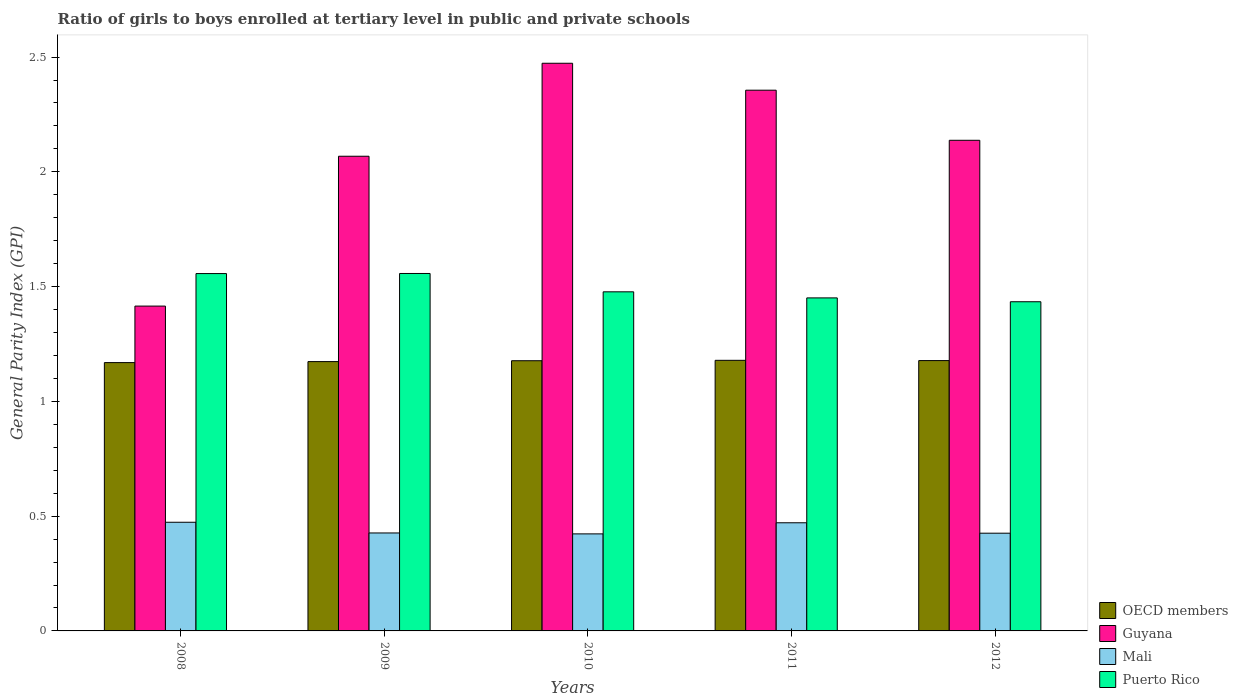How many different coloured bars are there?
Offer a very short reply. 4. How many groups of bars are there?
Provide a succinct answer. 5. Are the number of bars per tick equal to the number of legend labels?
Offer a very short reply. Yes. How many bars are there on the 4th tick from the left?
Keep it short and to the point. 4. In how many cases, is the number of bars for a given year not equal to the number of legend labels?
Offer a very short reply. 0. What is the general parity index in Guyana in 2011?
Your response must be concise. 2.36. Across all years, what is the maximum general parity index in Mali?
Offer a terse response. 0.47. Across all years, what is the minimum general parity index in Puerto Rico?
Provide a short and direct response. 1.43. In which year was the general parity index in Puerto Rico maximum?
Provide a short and direct response. 2009. What is the total general parity index in Mali in the graph?
Your answer should be compact. 2.22. What is the difference between the general parity index in OECD members in 2009 and that in 2011?
Ensure brevity in your answer.  -0.01. What is the difference between the general parity index in Guyana in 2008 and the general parity index in Puerto Rico in 2012?
Provide a short and direct response. -0.02. What is the average general parity index in Guyana per year?
Ensure brevity in your answer.  2.09. In the year 2011, what is the difference between the general parity index in Mali and general parity index in OECD members?
Offer a terse response. -0.71. What is the ratio of the general parity index in Puerto Rico in 2010 to that in 2011?
Your response must be concise. 1.02. Is the general parity index in OECD members in 2008 less than that in 2009?
Provide a succinct answer. Yes. Is the difference between the general parity index in Mali in 2008 and 2010 greater than the difference between the general parity index in OECD members in 2008 and 2010?
Give a very brief answer. Yes. What is the difference between the highest and the second highest general parity index in Guyana?
Ensure brevity in your answer.  0.12. What is the difference between the highest and the lowest general parity index in Puerto Rico?
Your answer should be compact. 0.12. What does the 4th bar from the left in 2009 represents?
Give a very brief answer. Puerto Rico. How many bars are there?
Offer a terse response. 20. Are the values on the major ticks of Y-axis written in scientific E-notation?
Your answer should be very brief. No. Does the graph contain any zero values?
Give a very brief answer. No. Where does the legend appear in the graph?
Give a very brief answer. Bottom right. What is the title of the graph?
Your answer should be very brief. Ratio of girls to boys enrolled at tertiary level in public and private schools. Does "Malta" appear as one of the legend labels in the graph?
Give a very brief answer. No. What is the label or title of the X-axis?
Ensure brevity in your answer.  Years. What is the label or title of the Y-axis?
Provide a succinct answer. General Parity Index (GPI). What is the General Parity Index (GPI) in OECD members in 2008?
Offer a terse response. 1.17. What is the General Parity Index (GPI) of Guyana in 2008?
Make the answer very short. 1.42. What is the General Parity Index (GPI) of Mali in 2008?
Your answer should be compact. 0.47. What is the General Parity Index (GPI) in Puerto Rico in 2008?
Provide a short and direct response. 1.56. What is the General Parity Index (GPI) in OECD members in 2009?
Your answer should be very brief. 1.17. What is the General Parity Index (GPI) in Guyana in 2009?
Provide a succinct answer. 2.07. What is the General Parity Index (GPI) in Mali in 2009?
Your answer should be compact. 0.43. What is the General Parity Index (GPI) of Puerto Rico in 2009?
Provide a succinct answer. 1.56. What is the General Parity Index (GPI) of OECD members in 2010?
Give a very brief answer. 1.18. What is the General Parity Index (GPI) of Guyana in 2010?
Offer a terse response. 2.47. What is the General Parity Index (GPI) of Mali in 2010?
Make the answer very short. 0.42. What is the General Parity Index (GPI) in Puerto Rico in 2010?
Give a very brief answer. 1.48. What is the General Parity Index (GPI) in OECD members in 2011?
Your answer should be compact. 1.18. What is the General Parity Index (GPI) in Guyana in 2011?
Provide a short and direct response. 2.36. What is the General Parity Index (GPI) of Mali in 2011?
Offer a very short reply. 0.47. What is the General Parity Index (GPI) of Puerto Rico in 2011?
Your answer should be very brief. 1.45. What is the General Parity Index (GPI) of OECD members in 2012?
Offer a very short reply. 1.18. What is the General Parity Index (GPI) in Guyana in 2012?
Provide a short and direct response. 2.14. What is the General Parity Index (GPI) of Mali in 2012?
Ensure brevity in your answer.  0.43. What is the General Parity Index (GPI) of Puerto Rico in 2012?
Ensure brevity in your answer.  1.43. Across all years, what is the maximum General Parity Index (GPI) of OECD members?
Provide a succinct answer. 1.18. Across all years, what is the maximum General Parity Index (GPI) of Guyana?
Make the answer very short. 2.47. Across all years, what is the maximum General Parity Index (GPI) in Mali?
Your answer should be very brief. 0.47. Across all years, what is the maximum General Parity Index (GPI) in Puerto Rico?
Make the answer very short. 1.56. Across all years, what is the minimum General Parity Index (GPI) of OECD members?
Ensure brevity in your answer.  1.17. Across all years, what is the minimum General Parity Index (GPI) of Guyana?
Your answer should be compact. 1.42. Across all years, what is the minimum General Parity Index (GPI) of Mali?
Offer a very short reply. 0.42. Across all years, what is the minimum General Parity Index (GPI) in Puerto Rico?
Provide a succinct answer. 1.43. What is the total General Parity Index (GPI) in OECD members in the graph?
Give a very brief answer. 5.88. What is the total General Parity Index (GPI) in Guyana in the graph?
Your answer should be very brief. 10.45. What is the total General Parity Index (GPI) in Mali in the graph?
Provide a succinct answer. 2.22. What is the total General Parity Index (GPI) of Puerto Rico in the graph?
Give a very brief answer. 7.48. What is the difference between the General Parity Index (GPI) in OECD members in 2008 and that in 2009?
Make the answer very short. -0. What is the difference between the General Parity Index (GPI) in Guyana in 2008 and that in 2009?
Your answer should be compact. -0.65. What is the difference between the General Parity Index (GPI) of Mali in 2008 and that in 2009?
Provide a succinct answer. 0.05. What is the difference between the General Parity Index (GPI) of Puerto Rico in 2008 and that in 2009?
Your response must be concise. -0. What is the difference between the General Parity Index (GPI) in OECD members in 2008 and that in 2010?
Keep it short and to the point. -0.01. What is the difference between the General Parity Index (GPI) in Guyana in 2008 and that in 2010?
Make the answer very short. -1.06. What is the difference between the General Parity Index (GPI) of Mali in 2008 and that in 2010?
Your response must be concise. 0.05. What is the difference between the General Parity Index (GPI) in Puerto Rico in 2008 and that in 2010?
Your answer should be very brief. 0.08. What is the difference between the General Parity Index (GPI) in OECD members in 2008 and that in 2011?
Provide a succinct answer. -0.01. What is the difference between the General Parity Index (GPI) of Guyana in 2008 and that in 2011?
Make the answer very short. -0.94. What is the difference between the General Parity Index (GPI) in Mali in 2008 and that in 2011?
Provide a short and direct response. 0. What is the difference between the General Parity Index (GPI) of Puerto Rico in 2008 and that in 2011?
Make the answer very short. 0.11. What is the difference between the General Parity Index (GPI) in OECD members in 2008 and that in 2012?
Provide a short and direct response. -0.01. What is the difference between the General Parity Index (GPI) in Guyana in 2008 and that in 2012?
Offer a terse response. -0.72. What is the difference between the General Parity Index (GPI) in Mali in 2008 and that in 2012?
Provide a short and direct response. 0.05. What is the difference between the General Parity Index (GPI) in Puerto Rico in 2008 and that in 2012?
Keep it short and to the point. 0.12. What is the difference between the General Parity Index (GPI) in OECD members in 2009 and that in 2010?
Your answer should be compact. -0. What is the difference between the General Parity Index (GPI) in Guyana in 2009 and that in 2010?
Ensure brevity in your answer.  -0.41. What is the difference between the General Parity Index (GPI) of Mali in 2009 and that in 2010?
Give a very brief answer. 0. What is the difference between the General Parity Index (GPI) of Puerto Rico in 2009 and that in 2010?
Give a very brief answer. 0.08. What is the difference between the General Parity Index (GPI) of OECD members in 2009 and that in 2011?
Ensure brevity in your answer.  -0.01. What is the difference between the General Parity Index (GPI) of Guyana in 2009 and that in 2011?
Your answer should be compact. -0.29. What is the difference between the General Parity Index (GPI) in Mali in 2009 and that in 2011?
Give a very brief answer. -0.04. What is the difference between the General Parity Index (GPI) in Puerto Rico in 2009 and that in 2011?
Give a very brief answer. 0.11. What is the difference between the General Parity Index (GPI) in OECD members in 2009 and that in 2012?
Keep it short and to the point. -0. What is the difference between the General Parity Index (GPI) in Guyana in 2009 and that in 2012?
Your response must be concise. -0.07. What is the difference between the General Parity Index (GPI) in Mali in 2009 and that in 2012?
Ensure brevity in your answer.  0. What is the difference between the General Parity Index (GPI) in Puerto Rico in 2009 and that in 2012?
Offer a terse response. 0.12. What is the difference between the General Parity Index (GPI) in OECD members in 2010 and that in 2011?
Provide a succinct answer. -0. What is the difference between the General Parity Index (GPI) of Guyana in 2010 and that in 2011?
Keep it short and to the point. 0.12. What is the difference between the General Parity Index (GPI) of Mali in 2010 and that in 2011?
Provide a short and direct response. -0.05. What is the difference between the General Parity Index (GPI) of Puerto Rico in 2010 and that in 2011?
Make the answer very short. 0.03. What is the difference between the General Parity Index (GPI) of OECD members in 2010 and that in 2012?
Your answer should be very brief. -0. What is the difference between the General Parity Index (GPI) of Guyana in 2010 and that in 2012?
Keep it short and to the point. 0.34. What is the difference between the General Parity Index (GPI) in Mali in 2010 and that in 2012?
Provide a succinct answer. -0. What is the difference between the General Parity Index (GPI) in Puerto Rico in 2010 and that in 2012?
Provide a short and direct response. 0.04. What is the difference between the General Parity Index (GPI) in OECD members in 2011 and that in 2012?
Provide a short and direct response. 0. What is the difference between the General Parity Index (GPI) of Guyana in 2011 and that in 2012?
Keep it short and to the point. 0.22. What is the difference between the General Parity Index (GPI) of Mali in 2011 and that in 2012?
Ensure brevity in your answer.  0.05. What is the difference between the General Parity Index (GPI) of Puerto Rico in 2011 and that in 2012?
Offer a very short reply. 0.02. What is the difference between the General Parity Index (GPI) of OECD members in 2008 and the General Parity Index (GPI) of Guyana in 2009?
Your answer should be very brief. -0.9. What is the difference between the General Parity Index (GPI) in OECD members in 2008 and the General Parity Index (GPI) in Mali in 2009?
Offer a terse response. 0.74. What is the difference between the General Parity Index (GPI) in OECD members in 2008 and the General Parity Index (GPI) in Puerto Rico in 2009?
Give a very brief answer. -0.39. What is the difference between the General Parity Index (GPI) in Guyana in 2008 and the General Parity Index (GPI) in Mali in 2009?
Give a very brief answer. 0.99. What is the difference between the General Parity Index (GPI) of Guyana in 2008 and the General Parity Index (GPI) of Puerto Rico in 2009?
Your response must be concise. -0.14. What is the difference between the General Parity Index (GPI) in Mali in 2008 and the General Parity Index (GPI) in Puerto Rico in 2009?
Your response must be concise. -1.08. What is the difference between the General Parity Index (GPI) in OECD members in 2008 and the General Parity Index (GPI) in Guyana in 2010?
Make the answer very short. -1.3. What is the difference between the General Parity Index (GPI) of OECD members in 2008 and the General Parity Index (GPI) of Mali in 2010?
Provide a short and direct response. 0.75. What is the difference between the General Parity Index (GPI) of OECD members in 2008 and the General Parity Index (GPI) of Puerto Rico in 2010?
Offer a very short reply. -0.31. What is the difference between the General Parity Index (GPI) of Guyana in 2008 and the General Parity Index (GPI) of Puerto Rico in 2010?
Offer a terse response. -0.06. What is the difference between the General Parity Index (GPI) in Mali in 2008 and the General Parity Index (GPI) in Puerto Rico in 2010?
Provide a succinct answer. -1. What is the difference between the General Parity Index (GPI) in OECD members in 2008 and the General Parity Index (GPI) in Guyana in 2011?
Your answer should be compact. -1.19. What is the difference between the General Parity Index (GPI) in OECD members in 2008 and the General Parity Index (GPI) in Mali in 2011?
Give a very brief answer. 0.7. What is the difference between the General Parity Index (GPI) of OECD members in 2008 and the General Parity Index (GPI) of Puerto Rico in 2011?
Make the answer very short. -0.28. What is the difference between the General Parity Index (GPI) of Guyana in 2008 and the General Parity Index (GPI) of Mali in 2011?
Provide a succinct answer. 0.94. What is the difference between the General Parity Index (GPI) in Guyana in 2008 and the General Parity Index (GPI) in Puerto Rico in 2011?
Your answer should be compact. -0.04. What is the difference between the General Parity Index (GPI) in Mali in 2008 and the General Parity Index (GPI) in Puerto Rico in 2011?
Offer a very short reply. -0.98. What is the difference between the General Parity Index (GPI) of OECD members in 2008 and the General Parity Index (GPI) of Guyana in 2012?
Make the answer very short. -0.97. What is the difference between the General Parity Index (GPI) of OECD members in 2008 and the General Parity Index (GPI) of Mali in 2012?
Provide a short and direct response. 0.74. What is the difference between the General Parity Index (GPI) in OECD members in 2008 and the General Parity Index (GPI) in Puerto Rico in 2012?
Your answer should be compact. -0.27. What is the difference between the General Parity Index (GPI) in Guyana in 2008 and the General Parity Index (GPI) in Puerto Rico in 2012?
Ensure brevity in your answer.  -0.02. What is the difference between the General Parity Index (GPI) of Mali in 2008 and the General Parity Index (GPI) of Puerto Rico in 2012?
Your response must be concise. -0.96. What is the difference between the General Parity Index (GPI) of OECD members in 2009 and the General Parity Index (GPI) of Guyana in 2010?
Provide a succinct answer. -1.3. What is the difference between the General Parity Index (GPI) in OECD members in 2009 and the General Parity Index (GPI) in Mali in 2010?
Give a very brief answer. 0.75. What is the difference between the General Parity Index (GPI) of OECD members in 2009 and the General Parity Index (GPI) of Puerto Rico in 2010?
Provide a short and direct response. -0.3. What is the difference between the General Parity Index (GPI) of Guyana in 2009 and the General Parity Index (GPI) of Mali in 2010?
Offer a very short reply. 1.65. What is the difference between the General Parity Index (GPI) of Guyana in 2009 and the General Parity Index (GPI) of Puerto Rico in 2010?
Your answer should be very brief. 0.59. What is the difference between the General Parity Index (GPI) in Mali in 2009 and the General Parity Index (GPI) in Puerto Rico in 2010?
Offer a very short reply. -1.05. What is the difference between the General Parity Index (GPI) of OECD members in 2009 and the General Parity Index (GPI) of Guyana in 2011?
Provide a succinct answer. -1.18. What is the difference between the General Parity Index (GPI) of OECD members in 2009 and the General Parity Index (GPI) of Mali in 2011?
Provide a short and direct response. 0.7. What is the difference between the General Parity Index (GPI) in OECD members in 2009 and the General Parity Index (GPI) in Puerto Rico in 2011?
Provide a short and direct response. -0.28. What is the difference between the General Parity Index (GPI) of Guyana in 2009 and the General Parity Index (GPI) of Mali in 2011?
Your answer should be very brief. 1.6. What is the difference between the General Parity Index (GPI) in Guyana in 2009 and the General Parity Index (GPI) in Puerto Rico in 2011?
Provide a short and direct response. 0.62. What is the difference between the General Parity Index (GPI) of Mali in 2009 and the General Parity Index (GPI) of Puerto Rico in 2011?
Ensure brevity in your answer.  -1.02. What is the difference between the General Parity Index (GPI) in OECD members in 2009 and the General Parity Index (GPI) in Guyana in 2012?
Offer a very short reply. -0.96. What is the difference between the General Parity Index (GPI) of OECD members in 2009 and the General Parity Index (GPI) of Mali in 2012?
Keep it short and to the point. 0.75. What is the difference between the General Parity Index (GPI) of OECD members in 2009 and the General Parity Index (GPI) of Puerto Rico in 2012?
Your answer should be very brief. -0.26. What is the difference between the General Parity Index (GPI) in Guyana in 2009 and the General Parity Index (GPI) in Mali in 2012?
Provide a succinct answer. 1.64. What is the difference between the General Parity Index (GPI) of Guyana in 2009 and the General Parity Index (GPI) of Puerto Rico in 2012?
Give a very brief answer. 0.63. What is the difference between the General Parity Index (GPI) in Mali in 2009 and the General Parity Index (GPI) in Puerto Rico in 2012?
Your answer should be very brief. -1.01. What is the difference between the General Parity Index (GPI) in OECD members in 2010 and the General Parity Index (GPI) in Guyana in 2011?
Your answer should be compact. -1.18. What is the difference between the General Parity Index (GPI) of OECD members in 2010 and the General Parity Index (GPI) of Mali in 2011?
Offer a very short reply. 0.71. What is the difference between the General Parity Index (GPI) of OECD members in 2010 and the General Parity Index (GPI) of Puerto Rico in 2011?
Make the answer very short. -0.27. What is the difference between the General Parity Index (GPI) of Guyana in 2010 and the General Parity Index (GPI) of Mali in 2011?
Your answer should be very brief. 2. What is the difference between the General Parity Index (GPI) of Guyana in 2010 and the General Parity Index (GPI) of Puerto Rico in 2011?
Give a very brief answer. 1.02. What is the difference between the General Parity Index (GPI) of Mali in 2010 and the General Parity Index (GPI) of Puerto Rico in 2011?
Offer a terse response. -1.03. What is the difference between the General Parity Index (GPI) in OECD members in 2010 and the General Parity Index (GPI) in Guyana in 2012?
Give a very brief answer. -0.96. What is the difference between the General Parity Index (GPI) of OECD members in 2010 and the General Parity Index (GPI) of Mali in 2012?
Your response must be concise. 0.75. What is the difference between the General Parity Index (GPI) in OECD members in 2010 and the General Parity Index (GPI) in Puerto Rico in 2012?
Keep it short and to the point. -0.26. What is the difference between the General Parity Index (GPI) in Guyana in 2010 and the General Parity Index (GPI) in Mali in 2012?
Your response must be concise. 2.05. What is the difference between the General Parity Index (GPI) of Guyana in 2010 and the General Parity Index (GPI) of Puerto Rico in 2012?
Provide a short and direct response. 1.04. What is the difference between the General Parity Index (GPI) of Mali in 2010 and the General Parity Index (GPI) of Puerto Rico in 2012?
Offer a terse response. -1.01. What is the difference between the General Parity Index (GPI) of OECD members in 2011 and the General Parity Index (GPI) of Guyana in 2012?
Provide a succinct answer. -0.96. What is the difference between the General Parity Index (GPI) in OECD members in 2011 and the General Parity Index (GPI) in Mali in 2012?
Your answer should be very brief. 0.75. What is the difference between the General Parity Index (GPI) in OECD members in 2011 and the General Parity Index (GPI) in Puerto Rico in 2012?
Provide a short and direct response. -0.26. What is the difference between the General Parity Index (GPI) in Guyana in 2011 and the General Parity Index (GPI) in Mali in 2012?
Your answer should be very brief. 1.93. What is the difference between the General Parity Index (GPI) of Guyana in 2011 and the General Parity Index (GPI) of Puerto Rico in 2012?
Make the answer very short. 0.92. What is the difference between the General Parity Index (GPI) in Mali in 2011 and the General Parity Index (GPI) in Puerto Rico in 2012?
Provide a succinct answer. -0.96. What is the average General Parity Index (GPI) of OECD members per year?
Make the answer very short. 1.18. What is the average General Parity Index (GPI) in Guyana per year?
Your answer should be very brief. 2.09. What is the average General Parity Index (GPI) in Mali per year?
Your answer should be compact. 0.44. What is the average General Parity Index (GPI) of Puerto Rico per year?
Provide a short and direct response. 1.5. In the year 2008, what is the difference between the General Parity Index (GPI) in OECD members and General Parity Index (GPI) in Guyana?
Ensure brevity in your answer.  -0.25. In the year 2008, what is the difference between the General Parity Index (GPI) in OECD members and General Parity Index (GPI) in Mali?
Provide a succinct answer. 0.7. In the year 2008, what is the difference between the General Parity Index (GPI) of OECD members and General Parity Index (GPI) of Puerto Rico?
Provide a short and direct response. -0.39. In the year 2008, what is the difference between the General Parity Index (GPI) in Guyana and General Parity Index (GPI) in Mali?
Your response must be concise. 0.94. In the year 2008, what is the difference between the General Parity Index (GPI) in Guyana and General Parity Index (GPI) in Puerto Rico?
Give a very brief answer. -0.14. In the year 2008, what is the difference between the General Parity Index (GPI) in Mali and General Parity Index (GPI) in Puerto Rico?
Offer a very short reply. -1.08. In the year 2009, what is the difference between the General Parity Index (GPI) in OECD members and General Parity Index (GPI) in Guyana?
Provide a short and direct response. -0.89. In the year 2009, what is the difference between the General Parity Index (GPI) of OECD members and General Parity Index (GPI) of Mali?
Make the answer very short. 0.75. In the year 2009, what is the difference between the General Parity Index (GPI) in OECD members and General Parity Index (GPI) in Puerto Rico?
Ensure brevity in your answer.  -0.38. In the year 2009, what is the difference between the General Parity Index (GPI) in Guyana and General Parity Index (GPI) in Mali?
Your answer should be compact. 1.64. In the year 2009, what is the difference between the General Parity Index (GPI) of Guyana and General Parity Index (GPI) of Puerto Rico?
Your answer should be very brief. 0.51. In the year 2009, what is the difference between the General Parity Index (GPI) in Mali and General Parity Index (GPI) in Puerto Rico?
Give a very brief answer. -1.13. In the year 2010, what is the difference between the General Parity Index (GPI) of OECD members and General Parity Index (GPI) of Guyana?
Provide a short and direct response. -1.3. In the year 2010, what is the difference between the General Parity Index (GPI) in OECD members and General Parity Index (GPI) in Mali?
Make the answer very short. 0.75. In the year 2010, what is the difference between the General Parity Index (GPI) in OECD members and General Parity Index (GPI) in Puerto Rico?
Ensure brevity in your answer.  -0.3. In the year 2010, what is the difference between the General Parity Index (GPI) of Guyana and General Parity Index (GPI) of Mali?
Offer a terse response. 2.05. In the year 2010, what is the difference between the General Parity Index (GPI) of Guyana and General Parity Index (GPI) of Puerto Rico?
Provide a short and direct response. 1. In the year 2010, what is the difference between the General Parity Index (GPI) of Mali and General Parity Index (GPI) of Puerto Rico?
Provide a short and direct response. -1.05. In the year 2011, what is the difference between the General Parity Index (GPI) in OECD members and General Parity Index (GPI) in Guyana?
Your answer should be compact. -1.18. In the year 2011, what is the difference between the General Parity Index (GPI) in OECD members and General Parity Index (GPI) in Mali?
Give a very brief answer. 0.71. In the year 2011, what is the difference between the General Parity Index (GPI) of OECD members and General Parity Index (GPI) of Puerto Rico?
Provide a succinct answer. -0.27. In the year 2011, what is the difference between the General Parity Index (GPI) in Guyana and General Parity Index (GPI) in Mali?
Ensure brevity in your answer.  1.88. In the year 2011, what is the difference between the General Parity Index (GPI) in Guyana and General Parity Index (GPI) in Puerto Rico?
Your answer should be compact. 0.9. In the year 2011, what is the difference between the General Parity Index (GPI) in Mali and General Parity Index (GPI) in Puerto Rico?
Provide a succinct answer. -0.98. In the year 2012, what is the difference between the General Parity Index (GPI) in OECD members and General Parity Index (GPI) in Guyana?
Offer a terse response. -0.96. In the year 2012, what is the difference between the General Parity Index (GPI) of OECD members and General Parity Index (GPI) of Mali?
Keep it short and to the point. 0.75. In the year 2012, what is the difference between the General Parity Index (GPI) in OECD members and General Parity Index (GPI) in Puerto Rico?
Your answer should be very brief. -0.26. In the year 2012, what is the difference between the General Parity Index (GPI) in Guyana and General Parity Index (GPI) in Mali?
Keep it short and to the point. 1.71. In the year 2012, what is the difference between the General Parity Index (GPI) of Guyana and General Parity Index (GPI) of Puerto Rico?
Your response must be concise. 0.7. In the year 2012, what is the difference between the General Parity Index (GPI) of Mali and General Parity Index (GPI) of Puerto Rico?
Your answer should be very brief. -1.01. What is the ratio of the General Parity Index (GPI) of OECD members in 2008 to that in 2009?
Your answer should be compact. 1. What is the ratio of the General Parity Index (GPI) in Guyana in 2008 to that in 2009?
Give a very brief answer. 0.68. What is the ratio of the General Parity Index (GPI) in Mali in 2008 to that in 2009?
Keep it short and to the point. 1.11. What is the ratio of the General Parity Index (GPI) of Guyana in 2008 to that in 2010?
Provide a succinct answer. 0.57. What is the ratio of the General Parity Index (GPI) of Mali in 2008 to that in 2010?
Keep it short and to the point. 1.12. What is the ratio of the General Parity Index (GPI) in Puerto Rico in 2008 to that in 2010?
Provide a succinct answer. 1.05. What is the ratio of the General Parity Index (GPI) in Guyana in 2008 to that in 2011?
Your answer should be compact. 0.6. What is the ratio of the General Parity Index (GPI) in Mali in 2008 to that in 2011?
Offer a very short reply. 1. What is the ratio of the General Parity Index (GPI) of Puerto Rico in 2008 to that in 2011?
Your response must be concise. 1.07. What is the ratio of the General Parity Index (GPI) in OECD members in 2008 to that in 2012?
Ensure brevity in your answer.  0.99. What is the ratio of the General Parity Index (GPI) of Guyana in 2008 to that in 2012?
Offer a very short reply. 0.66. What is the ratio of the General Parity Index (GPI) in Mali in 2008 to that in 2012?
Provide a short and direct response. 1.11. What is the ratio of the General Parity Index (GPI) in Puerto Rico in 2008 to that in 2012?
Provide a short and direct response. 1.09. What is the ratio of the General Parity Index (GPI) of Guyana in 2009 to that in 2010?
Give a very brief answer. 0.84. What is the ratio of the General Parity Index (GPI) in Mali in 2009 to that in 2010?
Ensure brevity in your answer.  1.01. What is the ratio of the General Parity Index (GPI) of Puerto Rico in 2009 to that in 2010?
Ensure brevity in your answer.  1.05. What is the ratio of the General Parity Index (GPI) of OECD members in 2009 to that in 2011?
Offer a terse response. 1. What is the ratio of the General Parity Index (GPI) of Guyana in 2009 to that in 2011?
Offer a very short reply. 0.88. What is the ratio of the General Parity Index (GPI) in Mali in 2009 to that in 2011?
Offer a terse response. 0.91. What is the ratio of the General Parity Index (GPI) of Puerto Rico in 2009 to that in 2011?
Provide a succinct answer. 1.07. What is the ratio of the General Parity Index (GPI) of OECD members in 2009 to that in 2012?
Make the answer very short. 1. What is the ratio of the General Parity Index (GPI) of Guyana in 2009 to that in 2012?
Provide a short and direct response. 0.97. What is the ratio of the General Parity Index (GPI) in Mali in 2009 to that in 2012?
Offer a very short reply. 1. What is the ratio of the General Parity Index (GPI) in Puerto Rico in 2009 to that in 2012?
Your answer should be very brief. 1.09. What is the ratio of the General Parity Index (GPI) of Guyana in 2010 to that in 2011?
Ensure brevity in your answer.  1.05. What is the ratio of the General Parity Index (GPI) of Mali in 2010 to that in 2011?
Provide a succinct answer. 0.9. What is the ratio of the General Parity Index (GPI) of Puerto Rico in 2010 to that in 2011?
Your answer should be compact. 1.02. What is the ratio of the General Parity Index (GPI) of Guyana in 2010 to that in 2012?
Offer a very short reply. 1.16. What is the ratio of the General Parity Index (GPI) in Mali in 2010 to that in 2012?
Ensure brevity in your answer.  0.99. What is the ratio of the General Parity Index (GPI) in Puerto Rico in 2010 to that in 2012?
Offer a very short reply. 1.03. What is the ratio of the General Parity Index (GPI) of Guyana in 2011 to that in 2012?
Make the answer very short. 1.1. What is the ratio of the General Parity Index (GPI) in Mali in 2011 to that in 2012?
Your answer should be very brief. 1.11. What is the ratio of the General Parity Index (GPI) of Puerto Rico in 2011 to that in 2012?
Keep it short and to the point. 1.01. What is the difference between the highest and the second highest General Parity Index (GPI) of OECD members?
Provide a short and direct response. 0. What is the difference between the highest and the second highest General Parity Index (GPI) of Guyana?
Offer a terse response. 0.12. What is the difference between the highest and the second highest General Parity Index (GPI) in Mali?
Provide a short and direct response. 0. What is the difference between the highest and the lowest General Parity Index (GPI) of OECD members?
Ensure brevity in your answer.  0.01. What is the difference between the highest and the lowest General Parity Index (GPI) in Guyana?
Keep it short and to the point. 1.06. What is the difference between the highest and the lowest General Parity Index (GPI) in Mali?
Ensure brevity in your answer.  0.05. What is the difference between the highest and the lowest General Parity Index (GPI) in Puerto Rico?
Offer a terse response. 0.12. 